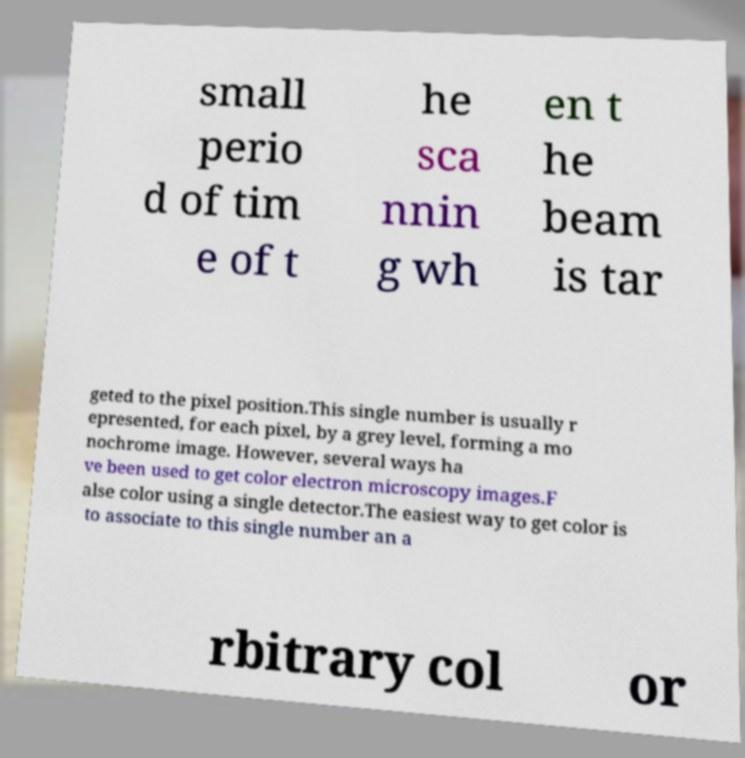Please read and relay the text visible in this image. What does it say? small perio d of tim e of t he sca nnin g wh en t he beam is tar geted to the pixel position.This single number is usually r epresented, for each pixel, by a grey level, forming a mo nochrome image. However, several ways ha ve been used to get color electron microscopy images.F alse color using a single detector.The easiest way to get color is to associate to this single number an a rbitrary col or 